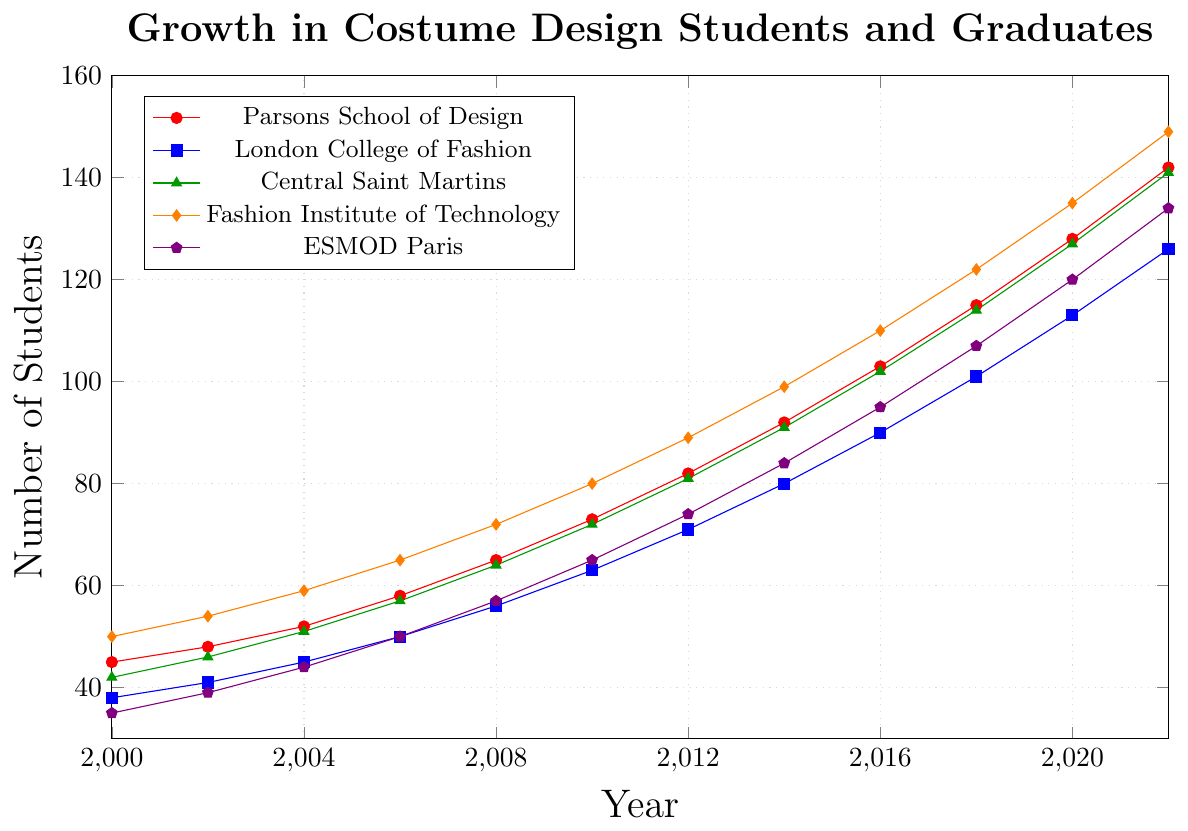What is the general trend for the number of students at all five schools between 2000 and 2022? The number of students at all five schools shows an increasing trend from 2000 to 2022. Each school has a consistent upward curve, indicating growth in the number of students over the years.
Answer: Increasing Which school had the highest number of students in 2022? In 2022, the Fashion Institute of Technology had the highest number of students, as indicated by the highest point on the plot corresponding to this school.
Answer: Fashion Institute of Technology How many more students were enrolled at Parsons School of Design in 2022 compared to 2010? To find the difference, look at the values for Parsons School of Design in 2022 and 2010. In 2022, there were 142 students, and in 2010, there were 73. The difference is 142 - 73.
Answer: 69 Which school has seen the most substantial growth in the number of students from 2000 to 2022? Calculate the difference between the 2022 and 2000 student numbers for each school: 
- Parsons: 142 - 45 = 97
- London: 126 - 38 = 88
- Central Saint Martins: 141 - 42 = 99
- FIT: 149 - 50 = 99 
- ESMOD: 134 - 35 = 99
Comparing these, Parsons, Central Saint Martins, FIT, and ESMOD all have the highest growth at 99 students.
Answer: Central Saint Martins or FIT or ESMOD Which school's student population reached 100 first, and in what year? Examine the curves to see which one crosses 100 first. The Fashion Institute of Technology reaches 100 students by 2014, which is the earliest among all schools.
Answer: Fashion Institute of Technology, 2014 What were the student numbers for Central Saint Martins in every leap year from 2000 to 2020? Central Saint Martins had the following student numbers in the given leap years:
- 2000: 42
- 2004: 51
- 2008: 64
- 2012: 81
- 2016: 102
- 2020: 127
Answer: 42, 51, 64, 81, 102, 127 